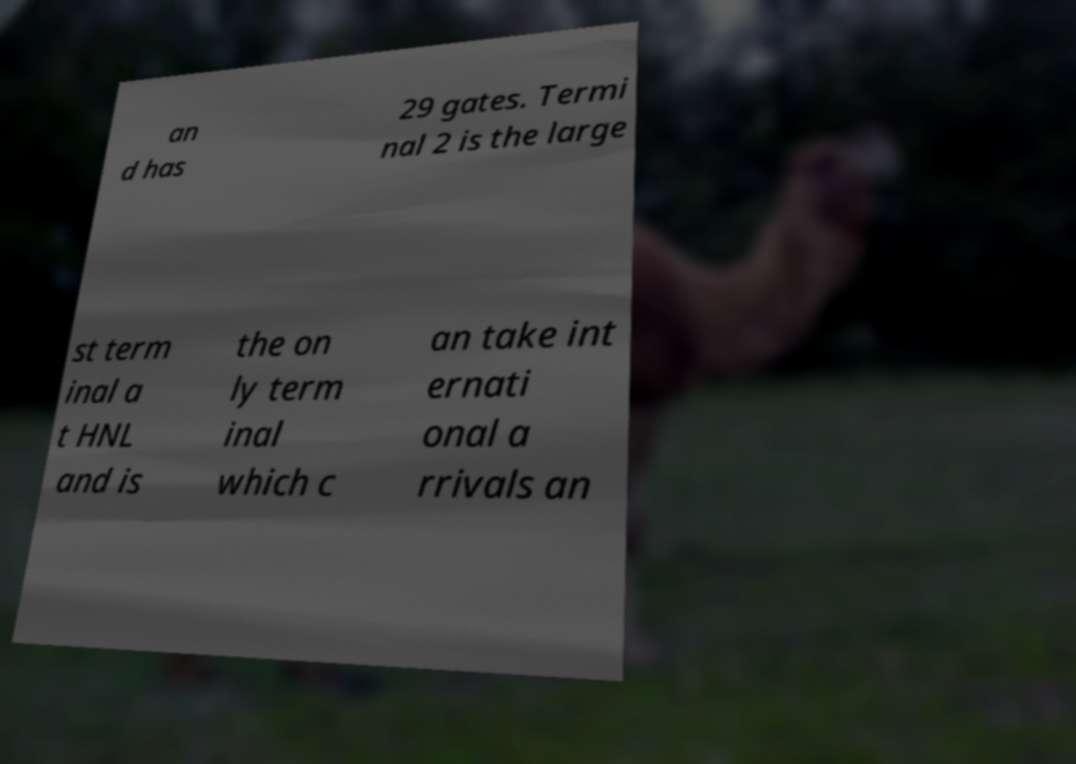Could you assist in decoding the text presented in this image and type it out clearly? an d has 29 gates. Termi nal 2 is the large st term inal a t HNL and is the on ly term inal which c an take int ernati onal a rrivals an 